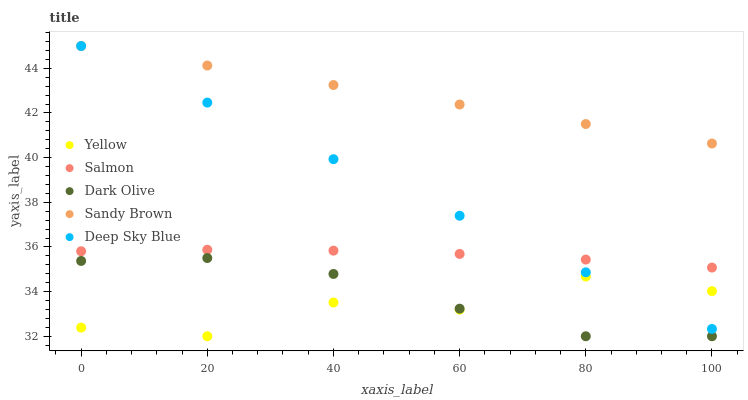Does Yellow have the minimum area under the curve?
Answer yes or no. Yes. Does Sandy Brown have the maximum area under the curve?
Answer yes or no. Yes. Does Dark Olive have the minimum area under the curve?
Answer yes or no. No. Does Dark Olive have the maximum area under the curve?
Answer yes or no. No. Is Sandy Brown the smoothest?
Answer yes or no. Yes. Is Yellow the roughest?
Answer yes or no. Yes. Is Dark Olive the smoothest?
Answer yes or no. No. Is Dark Olive the roughest?
Answer yes or no. No. Does Dark Olive have the lowest value?
Answer yes or no. Yes. Does Salmon have the lowest value?
Answer yes or no. No. Does Deep Sky Blue have the highest value?
Answer yes or no. Yes. Does Dark Olive have the highest value?
Answer yes or no. No. Is Yellow less than Sandy Brown?
Answer yes or no. Yes. Is Sandy Brown greater than Yellow?
Answer yes or no. Yes. Does Yellow intersect Dark Olive?
Answer yes or no. Yes. Is Yellow less than Dark Olive?
Answer yes or no. No. Is Yellow greater than Dark Olive?
Answer yes or no. No. Does Yellow intersect Sandy Brown?
Answer yes or no. No. 